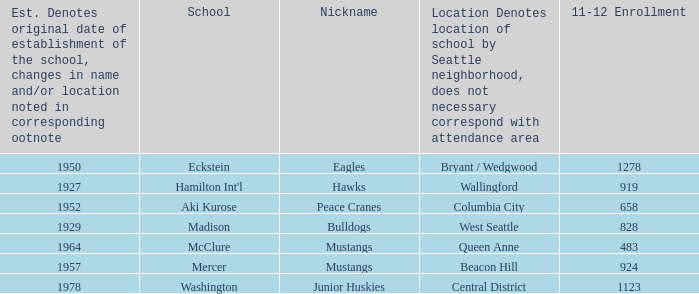Name the minimum 11-12 enrollment for washington school 1123.0. 